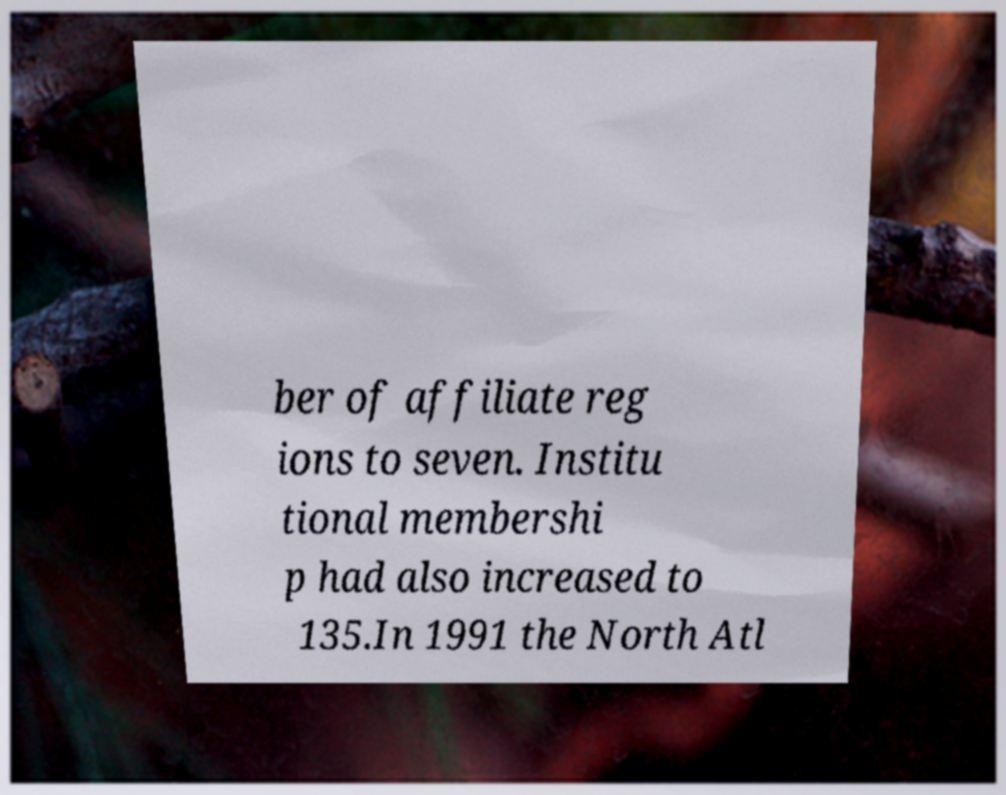Can you accurately transcribe the text from the provided image for me? ber of affiliate reg ions to seven. Institu tional membershi p had also increased to 135.In 1991 the North Atl 